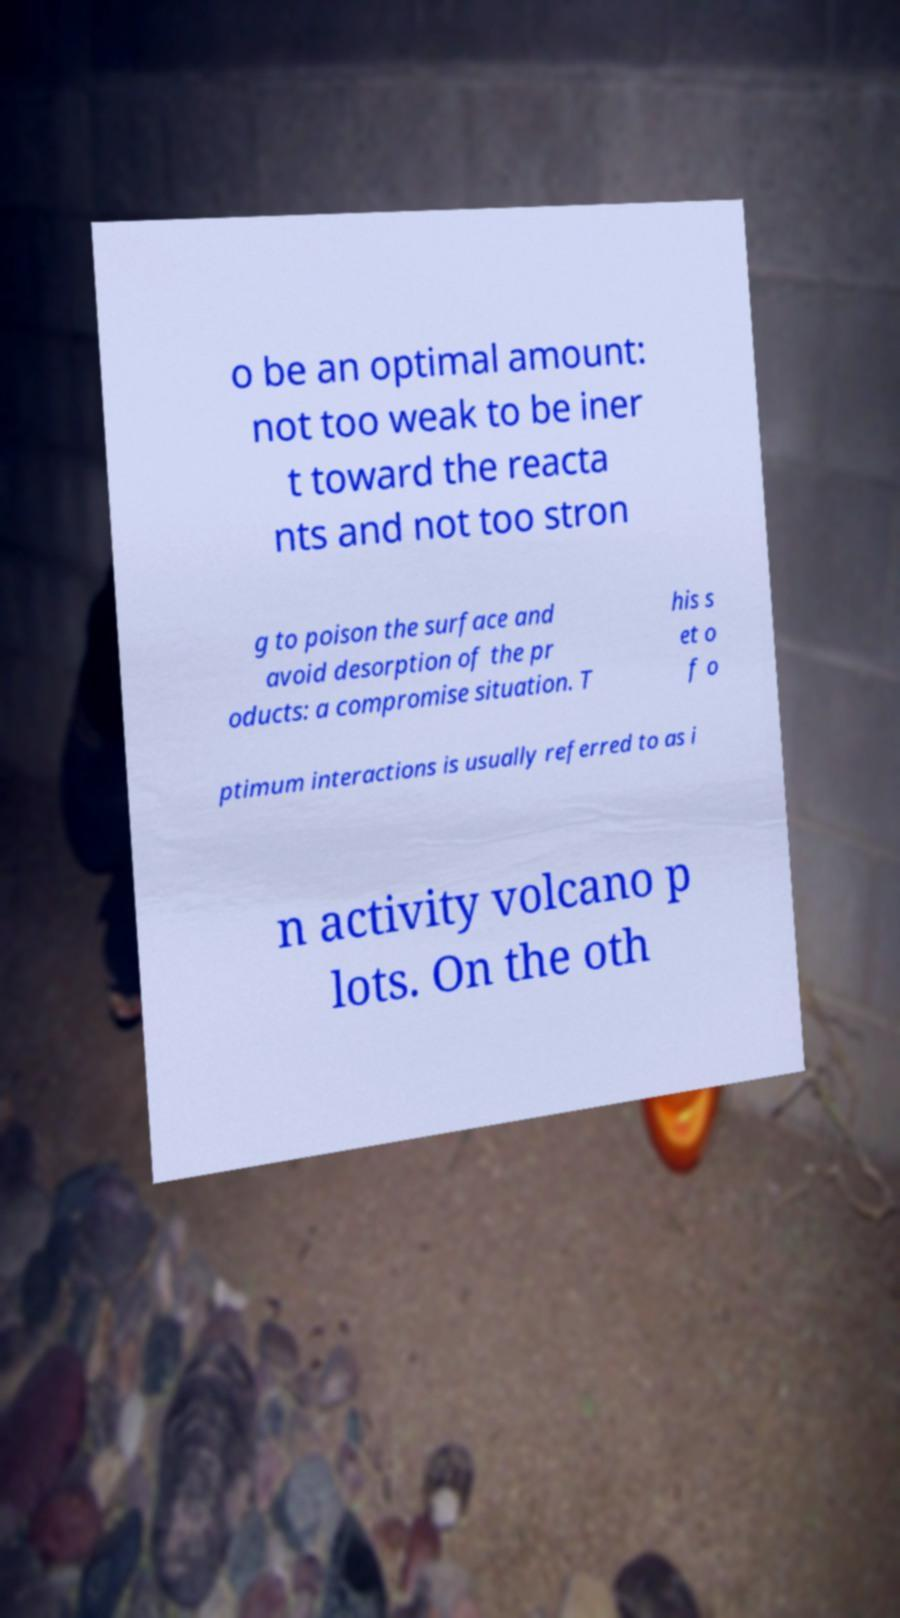Could you extract and type out the text from this image? o be an optimal amount: not too weak to be iner t toward the reacta nts and not too stron g to poison the surface and avoid desorption of the pr oducts: a compromise situation. T his s et o f o ptimum interactions is usually referred to as i n activity volcano p lots. On the oth 